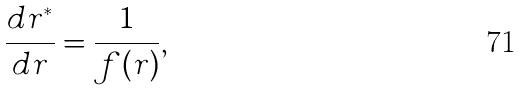Convert formula to latex. <formula><loc_0><loc_0><loc_500><loc_500>\frac { d r ^ { * } } { d r } = \frac { 1 } { f ( r ) } ,</formula> 